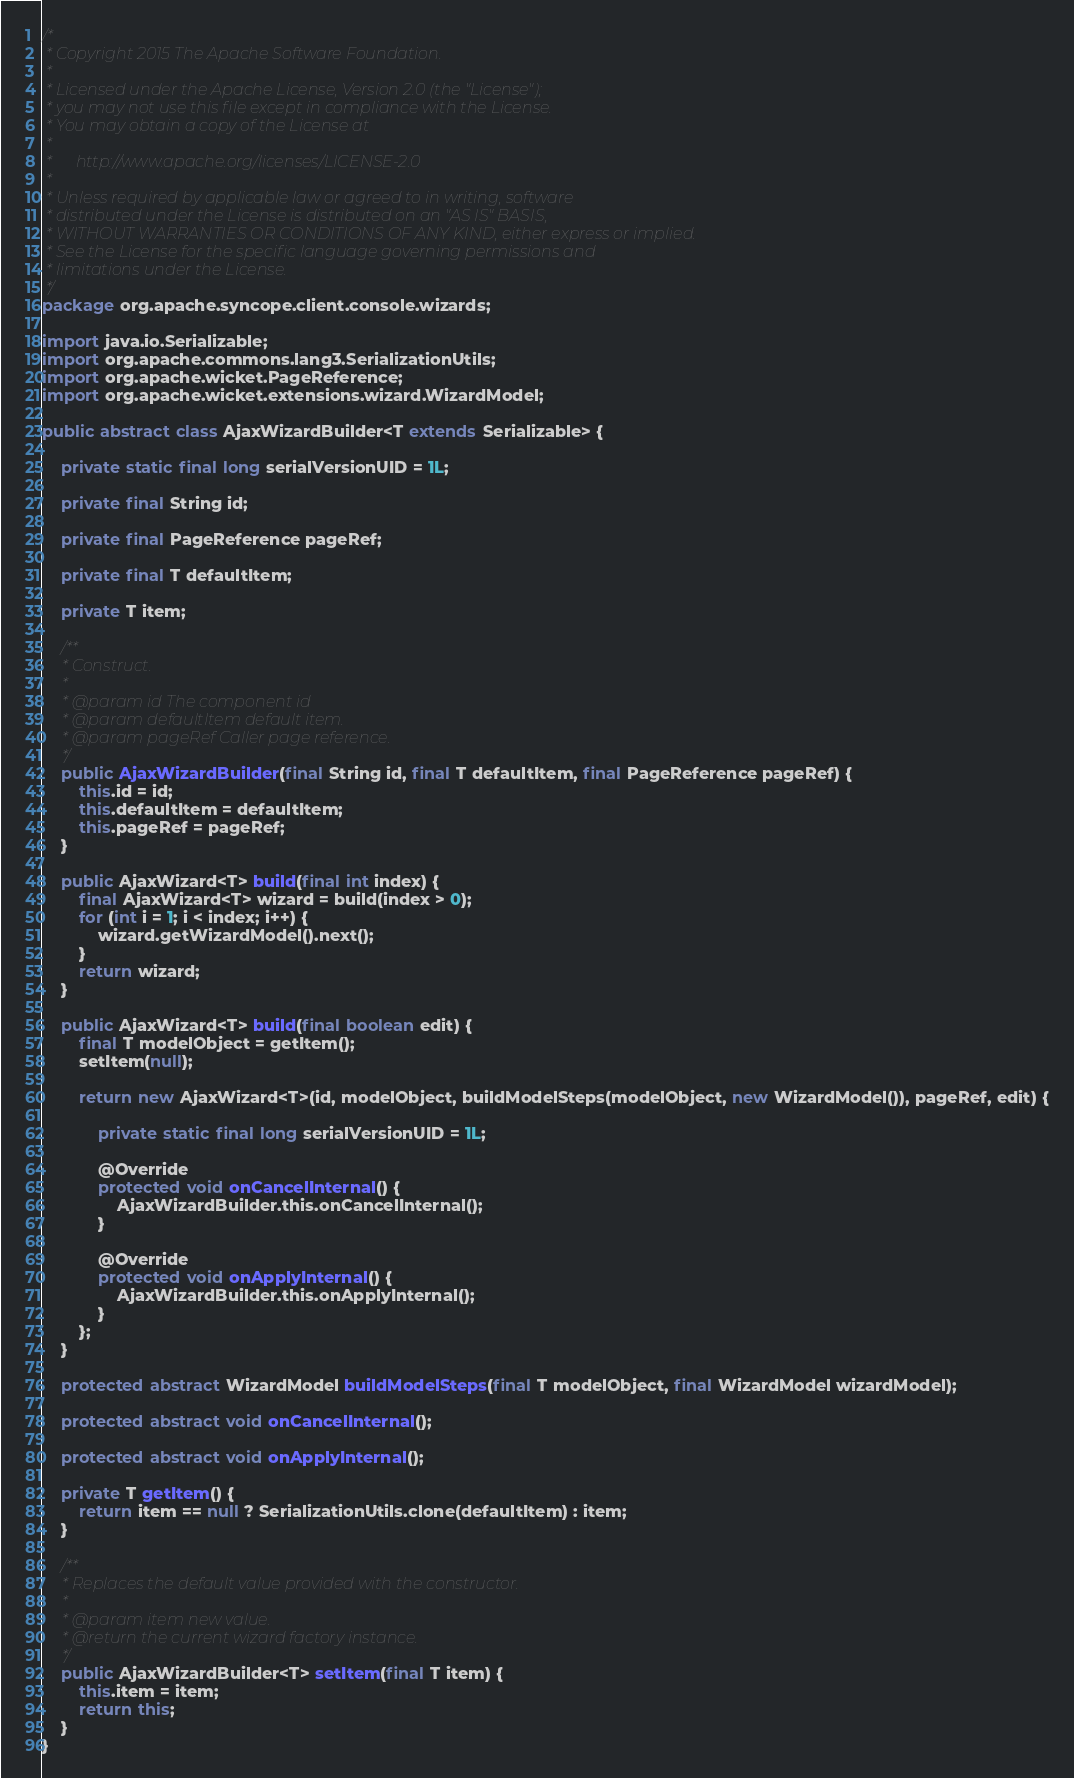<code> <loc_0><loc_0><loc_500><loc_500><_Java_>/*
 * Copyright 2015 The Apache Software Foundation.
 *
 * Licensed under the Apache License, Version 2.0 (the "License");
 * you may not use this file except in compliance with the License.
 * You may obtain a copy of the License at
 *
 *      http://www.apache.org/licenses/LICENSE-2.0
 *
 * Unless required by applicable law or agreed to in writing, software
 * distributed under the License is distributed on an "AS IS" BASIS,
 * WITHOUT WARRANTIES OR CONDITIONS OF ANY KIND, either express or implied.
 * See the License for the specific language governing permissions and
 * limitations under the License.
 */
package org.apache.syncope.client.console.wizards;

import java.io.Serializable;
import org.apache.commons.lang3.SerializationUtils;
import org.apache.wicket.PageReference;
import org.apache.wicket.extensions.wizard.WizardModel;

public abstract class AjaxWizardBuilder<T extends Serializable> {

    private static final long serialVersionUID = 1L;

    private final String id;

    private final PageReference pageRef;

    private final T defaultItem;

    private T item;

    /**
     * Construct.
     *
     * @param id The component id
     * @param defaultItem default item.
     * @param pageRef Caller page reference.
     */
    public AjaxWizardBuilder(final String id, final T defaultItem, final PageReference pageRef) {
        this.id = id;
        this.defaultItem = defaultItem;
        this.pageRef = pageRef;
    }

    public AjaxWizard<T> build(final int index) {
        final AjaxWizard<T> wizard = build(index > 0);
        for (int i = 1; i < index; i++) {
            wizard.getWizardModel().next();
        }
        return wizard;
    }

    public AjaxWizard<T> build(final boolean edit) {
        final T modelObject = getItem();
        setItem(null);

        return new AjaxWizard<T>(id, modelObject, buildModelSteps(modelObject, new WizardModel()), pageRef, edit) {

            private static final long serialVersionUID = 1L;

            @Override
            protected void onCancelInternal() {
                AjaxWizardBuilder.this.onCancelInternal();
            }

            @Override
            protected void onApplyInternal() {
                AjaxWizardBuilder.this.onApplyInternal();
            }
        };
    }

    protected abstract WizardModel buildModelSteps(final T modelObject, final WizardModel wizardModel);

    protected abstract void onCancelInternal();

    protected abstract void onApplyInternal();

    private T getItem() {
        return item == null ? SerializationUtils.clone(defaultItem) : item;
    }

    /**
     * Replaces the default value provided with the constructor.
     *
     * @param item new value.
     * @return the current wizard factory instance.
     */
    public AjaxWizardBuilder<T> setItem(final T item) {
        this.item = item;
        return this;
    }
}
</code> 